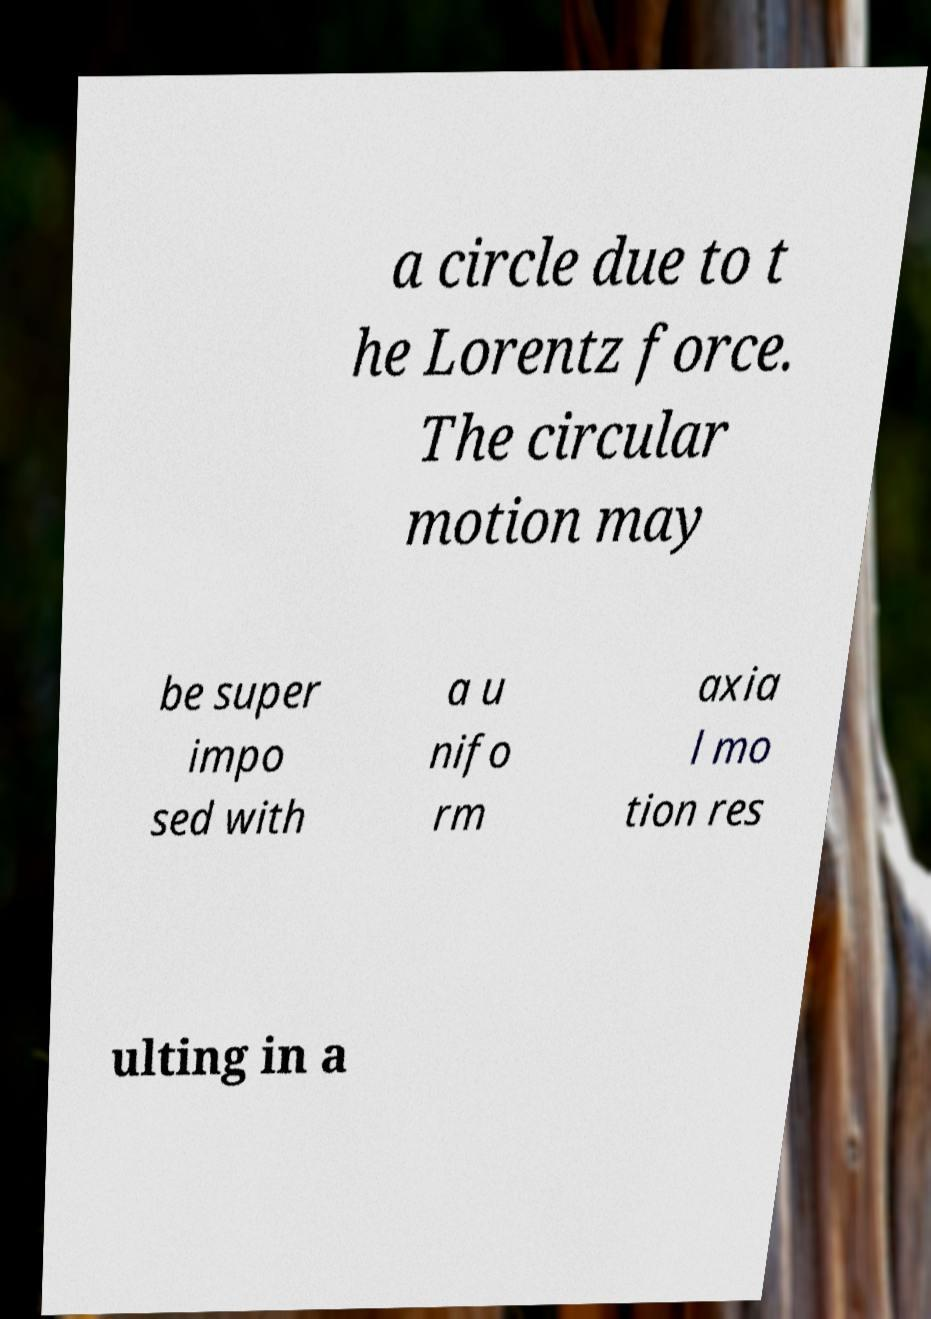Please read and relay the text visible in this image. What does it say? a circle due to t he Lorentz force. The circular motion may be super impo sed with a u nifo rm axia l mo tion res ulting in a 